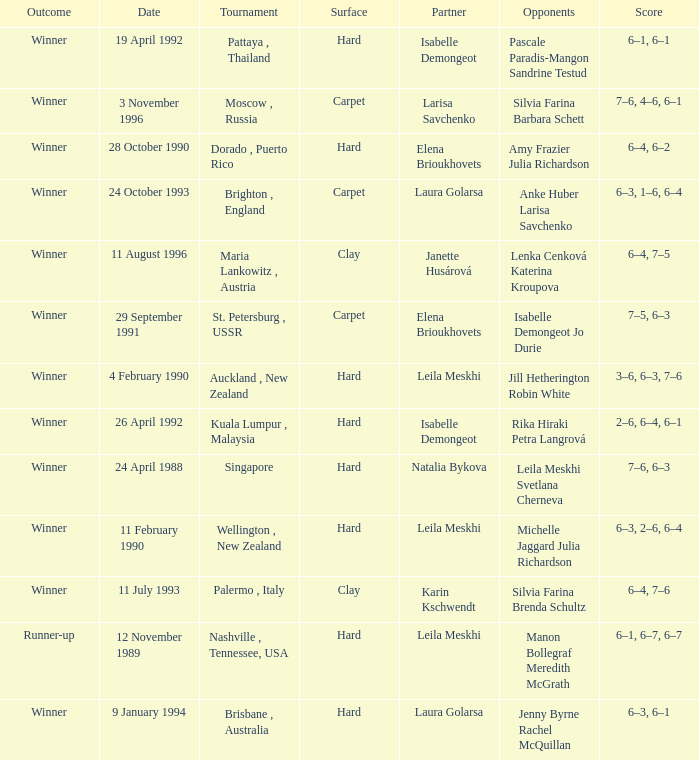On what Date was the Score 6–4, 6–2? 28 October 1990. 